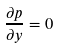<formula> <loc_0><loc_0><loc_500><loc_500>\frac { \partial p } { \partial y } = 0</formula> 